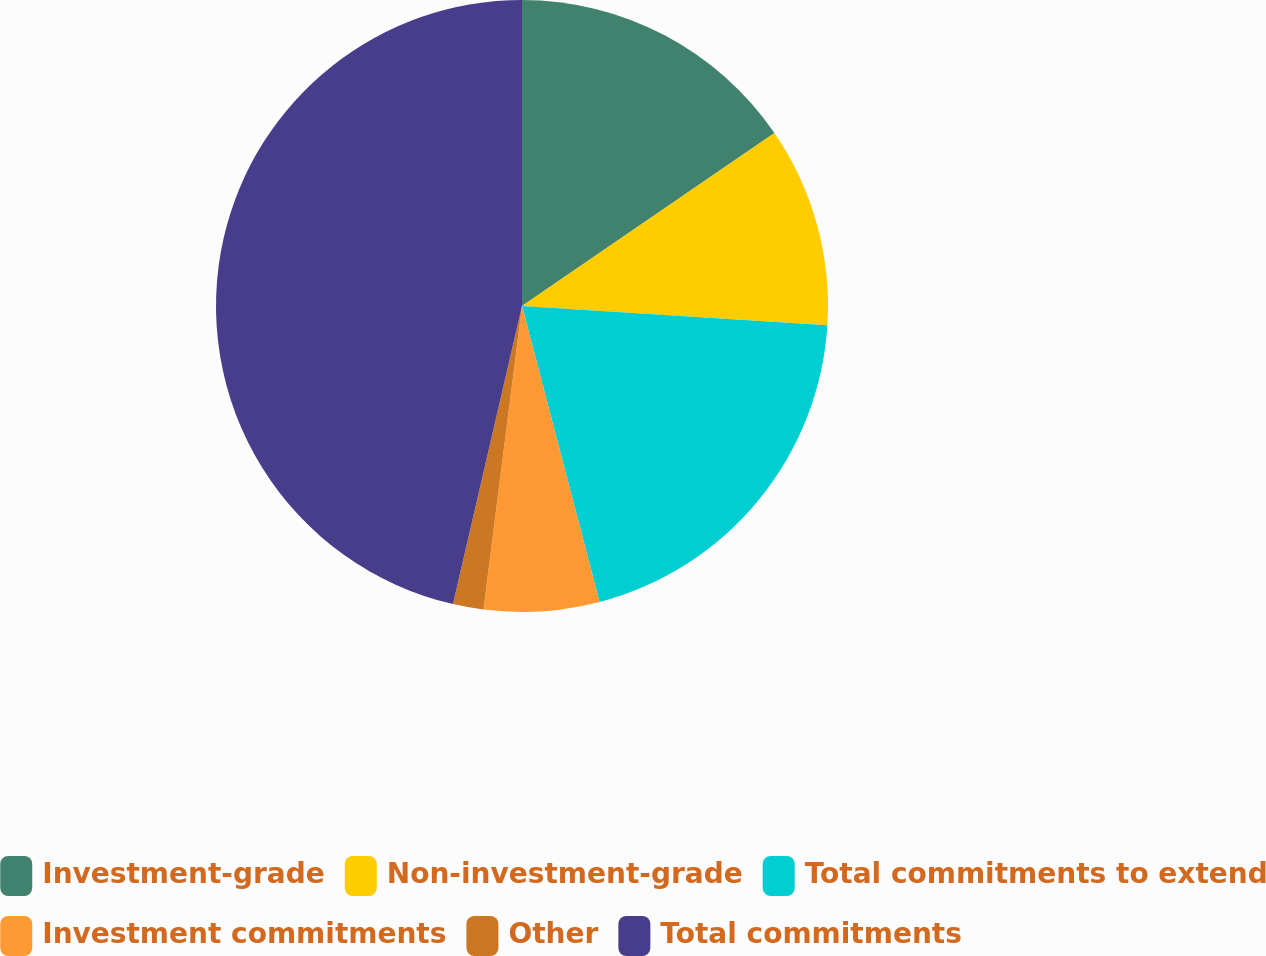Convert chart to OTSL. <chart><loc_0><loc_0><loc_500><loc_500><pie_chart><fcel>Investment-grade<fcel>Non-investment-grade<fcel>Total commitments to extend<fcel>Investment commitments<fcel>Other<fcel>Total commitments<nl><fcel>15.44%<fcel>10.56%<fcel>19.92%<fcel>6.09%<fcel>1.61%<fcel>46.38%<nl></chart> 